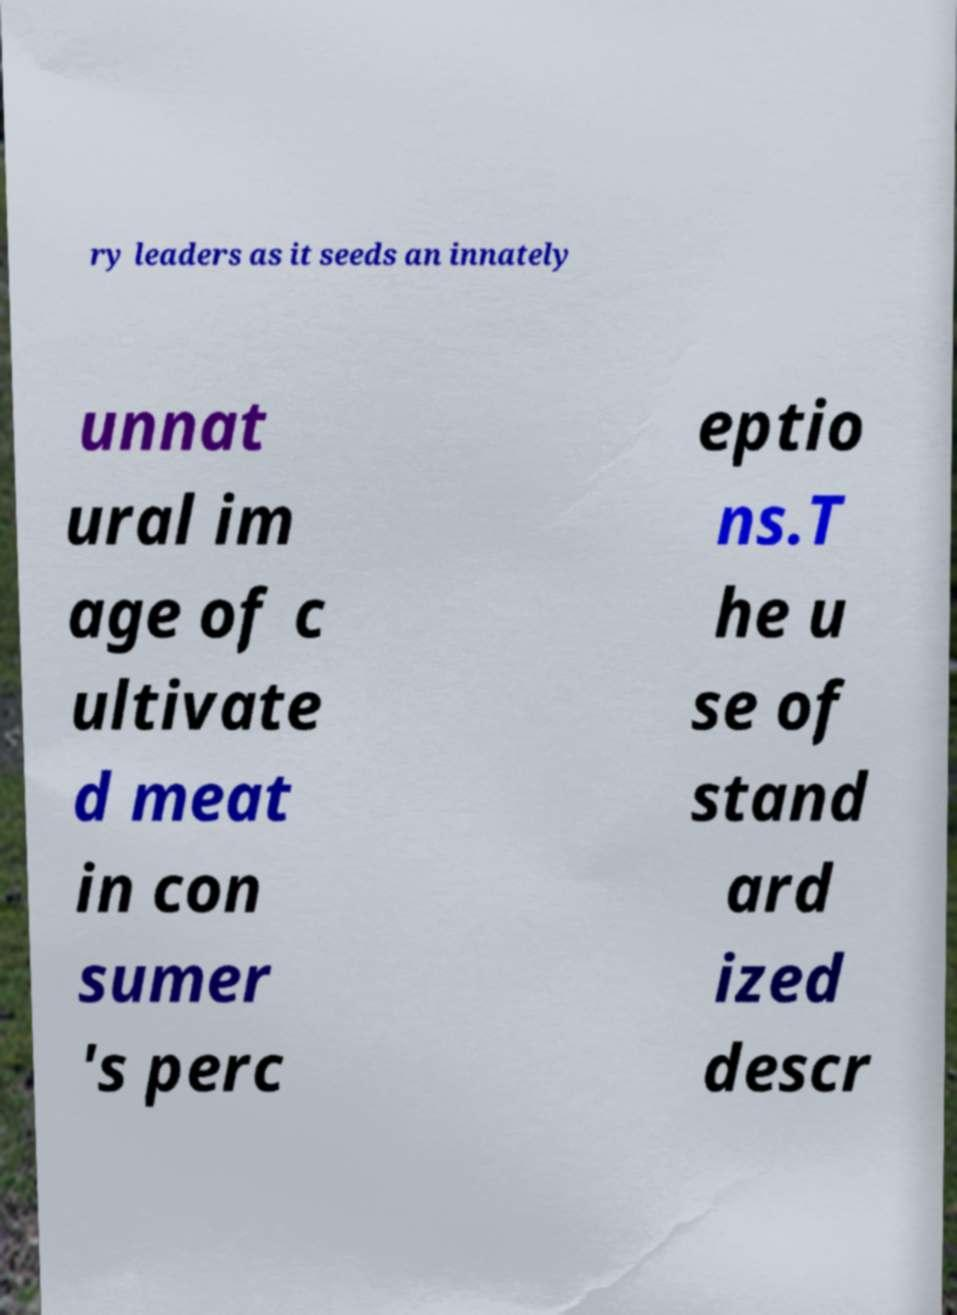Could you extract and type out the text from this image? ry leaders as it seeds an innately unnat ural im age of c ultivate d meat in con sumer 's perc eptio ns.T he u se of stand ard ized descr 